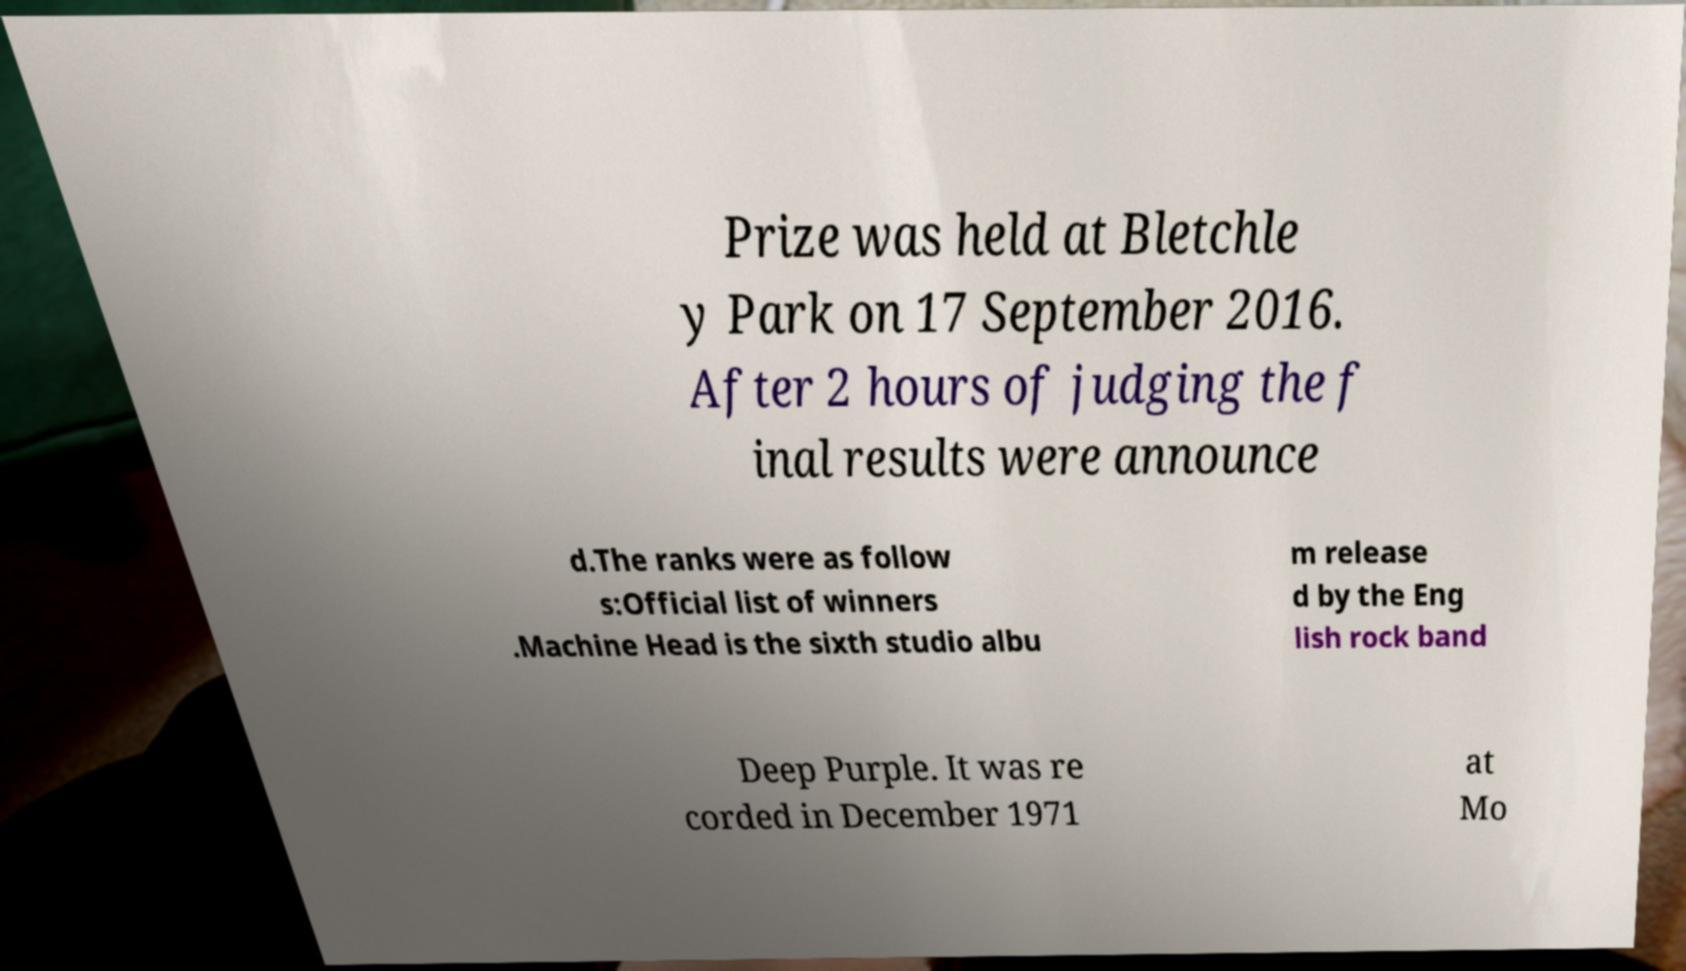Could you assist in decoding the text presented in this image and type it out clearly? Prize was held at Bletchle y Park on 17 September 2016. After 2 hours of judging the f inal results were announce d.The ranks were as follow s:Official list of winners .Machine Head is the sixth studio albu m release d by the Eng lish rock band Deep Purple. It was re corded in December 1971 at Mo 